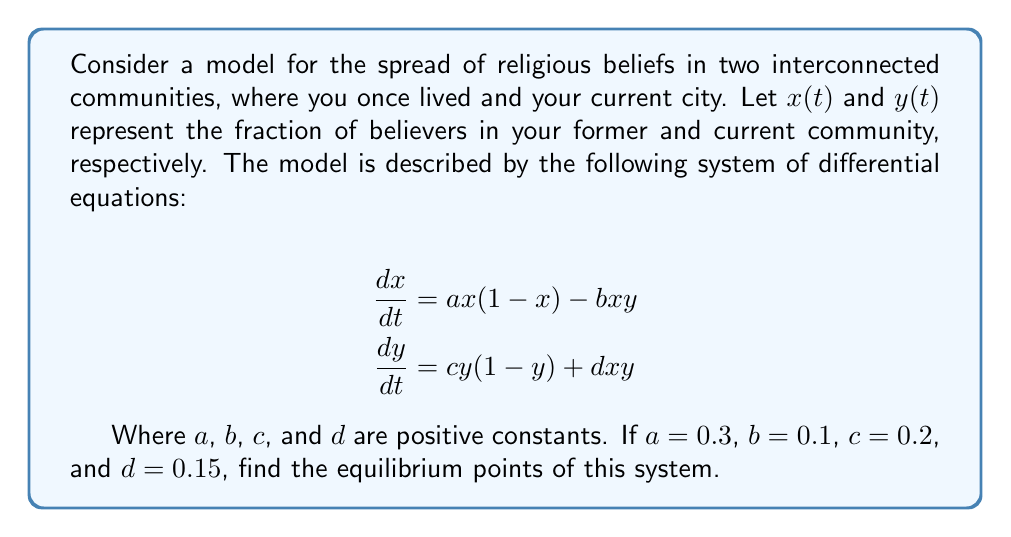What is the answer to this math problem? To find the equilibrium points, we need to set both equations equal to zero and solve for $x$ and $y$:

1) Set $\frac{dx}{dt} = 0$ and $\frac{dy}{dt} = 0$:

   $$\begin{align}
   0 &= ax(1-x) - bxy \\
   0 &= cy(1-y) + dxy
   \end{align}$$

2) Substitute the given values:

   $$\begin{align}
   0 &= 0.3x(1-x) - 0.1xy \\
   0 &= 0.2y(1-y) + 0.15xy
   \end{align}$$

3) From these equations, we can see that $(0,0)$ is always an equilibrium point.

4) For non-zero solutions, factor out $x$ from the first equation and $y$ from the second:

   $$\begin{align}
   x(0.3 - 0.3x - 0.1y) &= 0 \\
   y(0.2 - 0.2y + 0.15x) &= 0
   \end{align}$$

5) For non-zero $x$ and $y$, we must have:

   $$\begin{align}
   0.3 - 0.3x - 0.1y &= 0 \\
   0.2 - 0.2y + 0.15x &= 0
   \end{align}$$

6) From the first equation:
   $x = 1 - \frac{1}{3}y$

7) Substitute this into the second equation:

   $$0.2 - 0.2y + 0.15(1 - \frac{1}{3}y) = 0$$

8) Simplify:

   $$0.35 - 0.2y - 0.05y = 0$$
   $$0.35 - 0.25y = 0$$

9) Solve for $y$:

   $$y = \frac{0.35}{0.25} = 1.4$$

10) Substitute back to find $x$:

    $$x = 1 - \frac{1}{3}(1.4) = 0.5333...$$

Therefore, the equilibrium points are $(0,0)$ and $(0.5333..., 1.4)$.
Answer: $(0,0)$ and $(0.5333..., 1.4)$ 